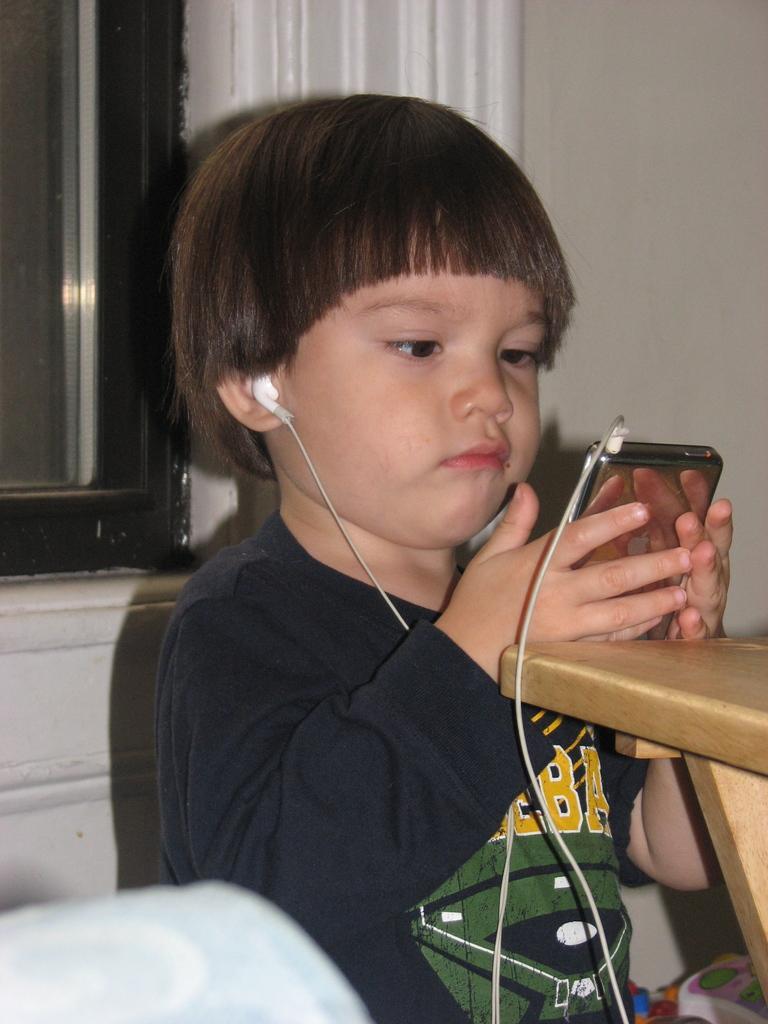Can you describe this image briefly? In this image there is a child holding a phone in his both hands and earphones are plugged in. There is a wall in the background. 